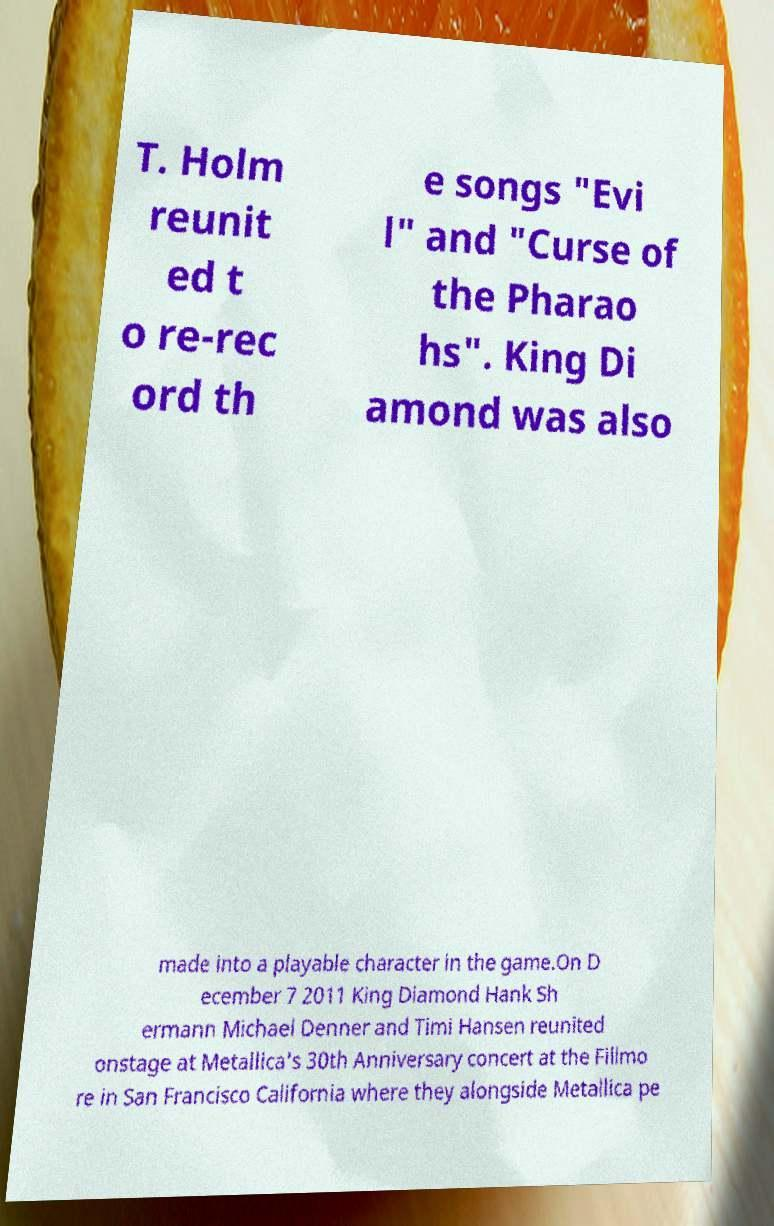Can you read and provide the text displayed in the image?This photo seems to have some interesting text. Can you extract and type it out for me? T. Holm reunit ed t o re-rec ord th e songs "Evi l" and "Curse of the Pharao hs". King Di amond was also made into a playable character in the game.On D ecember 7 2011 King Diamond Hank Sh ermann Michael Denner and Timi Hansen reunited onstage at Metallica's 30th Anniversary concert at the Fillmo re in San Francisco California where they alongside Metallica pe 